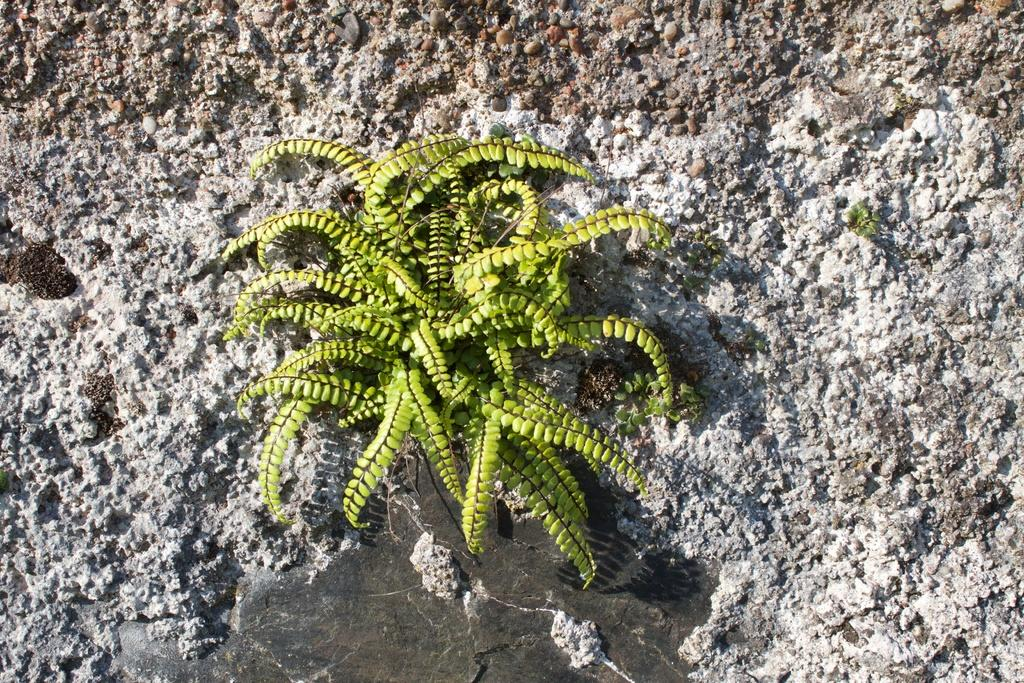What type of living organism is in the image? There is a plant in the image. Can you describe the leaves of the plant? The plant has small leaves. Where is the plant located in the image? The plant is on a surface. What color is the vest hanging on the wall in the image? There is no vest or wall present in the image; it only features a plant with small leaves on a surface. 